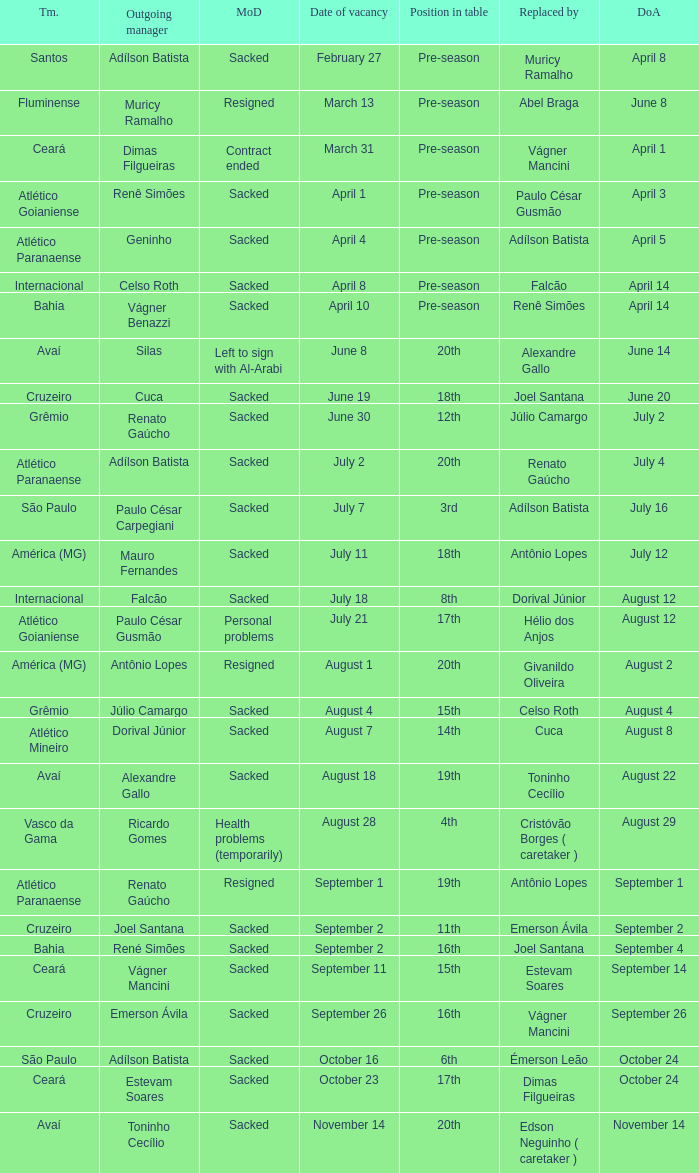Why did Geninho leave as manager? Sacked. 